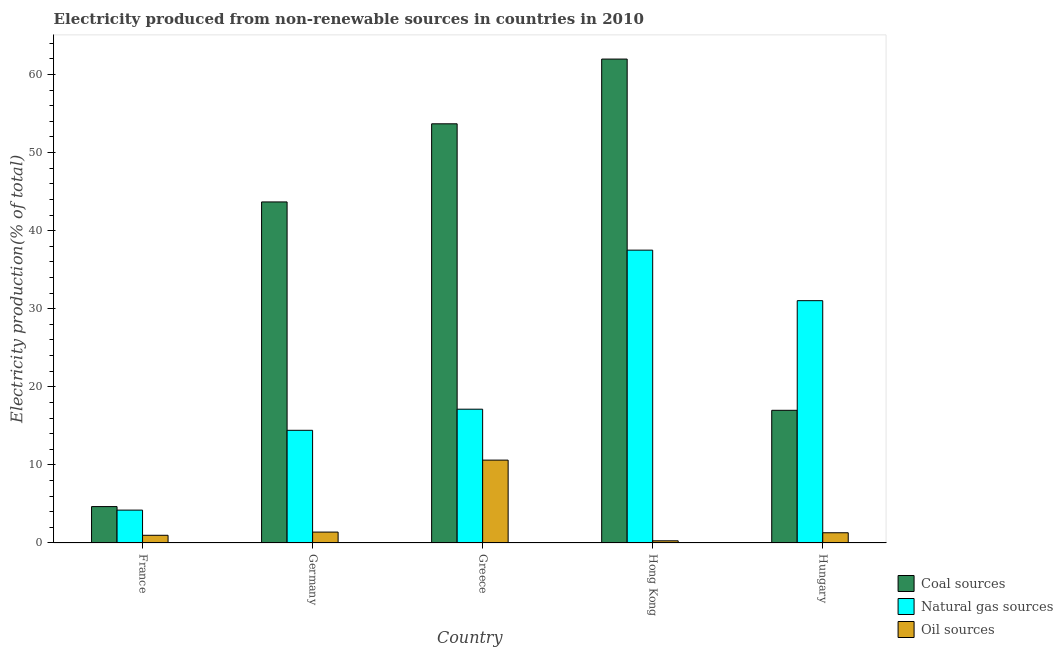How many different coloured bars are there?
Offer a very short reply. 3. How many groups of bars are there?
Make the answer very short. 5. Are the number of bars on each tick of the X-axis equal?
Ensure brevity in your answer.  Yes. What is the label of the 4th group of bars from the left?
Your answer should be compact. Hong Kong. In how many cases, is the number of bars for a given country not equal to the number of legend labels?
Provide a succinct answer. 0. What is the percentage of electricity produced by coal in France?
Give a very brief answer. 4.66. Across all countries, what is the maximum percentage of electricity produced by coal?
Make the answer very short. 61.98. Across all countries, what is the minimum percentage of electricity produced by natural gas?
Your answer should be compact. 4.21. In which country was the percentage of electricity produced by oil sources minimum?
Provide a succinct answer. Hong Kong. What is the total percentage of electricity produced by oil sources in the graph?
Provide a short and direct response. 14.59. What is the difference between the percentage of electricity produced by coal in Hong Kong and that in Hungary?
Ensure brevity in your answer.  44.98. What is the difference between the percentage of electricity produced by natural gas in Hong Kong and the percentage of electricity produced by oil sources in Greece?
Make the answer very short. 26.89. What is the average percentage of electricity produced by oil sources per country?
Your answer should be compact. 2.92. What is the difference between the percentage of electricity produced by natural gas and percentage of electricity produced by oil sources in France?
Provide a succinct answer. 3.22. In how many countries, is the percentage of electricity produced by oil sources greater than 48 %?
Make the answer very short. 0. What is the ratio of the percentage of electricity produced by natural gas in France to that in Germany?
Keep it short and to the point. 0.29. Is the percentage of electricity produced by natural gas in France less than that in Germany?
Your response must be concise. Yes. What is the difference between the highest and the second highest percentage of electricity produced by coal?
Give a very brief answer. 8.29. What is the difference between the highest and the lowest percentage of electricity produced by oil sources?
Offer a terse response. 10.34. In how many countries, is the percentage of electricity produced by natural gas greater than the average percentage of electricity produced by natural gas taken over all countries?
Your answer should be very brief. 2. Is the sum of the percentage of electricity produced by natural gas in France and Greece greater than the maximum percentage of electricity produced by coal across all countries?
Your answer should be compact. No. What does the 2nd bar from the left in Hungary represents?
Ensure brevity in your answer.  Natural gas sources. What does the 1st bar from the right in Germany represents?
Your response must be concise. Oil sources. What is the difference between two consecutive major ticks on the Y-axis?
Offer a very short reply. 10. Does the graph contain any zero values?
Provide a succinct answer. No. How many legend labels are there?
Ensure brevity in your answer.  3. How are the legend labels stacked?
Give a very brief answer. Vertical. What is the title of the graph?
Your answer should be very brief. Electricity produced from non-renewable sources in countries in 2010. What is the Electricity production(% of total) of Coal sources in France?
Make the answer very short. 4.66. What is the Electricity production(% of total) of Natural gas sources in France?
Make the answer very short. 4.21. What is the Electricity production(% of total) of Oil sources in France?
Make the answer very short. 0.99. What is the Electricity production(% of total) of Coal sources in Germany?
Your response must be concise. 43.68. What is the Electricity production(% of total) in Natural gas sources in Germany?
Offer a very short reply. 14.43. What is the Electricity production(% of total) of Oil sources in Germany?
Ensure brevity in your answer.  1.4. What is the Electricity production(% of total) of Coal sources in Greece?
Offer a terse response. 53.68. What is the Electricity production(% of total) in Natural gas sources in Greece?
Provide a succinct answer. 17.14. What is the Electricity production(% of total) of Oil sources in Greece?
Your answer should be compact. 10.61. What is the Electricity production(% of total) of Coal sources in Hong Kong?
Provide a succinct answer. 61.98. What is the Electricity production(% of total) in Natural gas sources in Hong Kong?
Keep it short and to the point. 37.5. What is the Electricity production(% of total) of Oil sources in Hong Kong?
Ensure brevity in your answer.  0.28. What is the Electricity production(% of total) of Coal sources in Hungary?
Your answer should be very brief. 16.99. What is the Electricity production(% of total) of Natural gas sources in Hungary?
Your answer should be compact. 31.03. What is the Electricity production(% of total) in Oil sources in Hungary?
Offer a terse response. 1.31. Across all countries, what is the maximum Electricity production(% of total) of Coal sources?
Your response must be concise. 61.98. Across all countries, what is the maximum Electricity production(% of total) in Natural gas sources?
Give a very brief answer. 37.5. Across all countries, what is the maximum Electricity production(% of total) of Oil sources?
Give a very brief answer. 10.61. Across all countries, what is the minimum Electricity production(% of total) of Coal sources?
Offer a terse response. 4.66. Across all countries, what is the minimum Electricity production(% of total) in Natural gas sources?
Provide a succinct answer. 4.21. Across all countries, what is the minimum Electricity production(% of total) of Oil sources?
Your answer should be compact. 0.28. What is the total Electricity production(% of total) in Coal sources in the graph?
Provide a succinct answer. 180.99. What is the total Electricity production(% of total) of Natural gas sources in the graph?
Your response must be concise. 104.32. What is the total Electricity production(% of total) of Oil sources in the graph?
Offer a terse response. 14.59. What is the difference between the Electricity production(% of total) in Coal sources in France and that in Germany?
Ensure brevity in your answer.  -39.02. What is the difference between the Electricity production(% of total) in Natural gas sources in France and that in Germany?
Your response must be concise. -10.22. What is the difference between the Electricity production(% of total) in Oil sources in France and that in Germany?
Your answer should be very brief. -0.41. What is the difference between the Electricity production(% of total) in Coal sources in France and that in Greece?
Provide a succinct answer. -49.02. What is the difference between the Electricity production(% of total) of Natural gas sources in France and that in Greece?
Provide a short and direct response. -12.93. What is the difference between the Electricity production(% of total) of Oil sources in France and that in Greece?
Your answer should be very brief. -9.63. What is the difference between the Electricity production(% of total) in Coal sources in France and that in Hong Kong?
Your answer should be very brief. -57.31. What is the difference between the Electricity production(% of total) of Natural gas sources in France and that in Hong Kong?
Provide a succinct answer. -33.29. What is the difference between the Electricity production(% of total) of Oil sources in France and that in Hong Kong?
Make the answer very short. 0.71. What is the difference between the Electricity production(% of total) of Coal sources in France and that in Hungary?
Keep it short and to the point. -12.33. What is the difference between the Electricity production(% of total) in Natural gas sources in France and that in Hungary?
Keep it short and to the point. -26.82. What is the difference between the Electricity production(% of total) of Oil sources in France and that in Hungary?
Give a very brief answer. -0.33. What is the difference between the Electricity production(% of total) of Coal sources in Germany and that in Greece?
Offer a very short reply. -10. What is the difference between the Electricity production(% of total) in Natural gas sources in Germany and that in Greece?
Your answer should be compact. -2.7. What is the difference between the Electricity production(% of total) in Oil sources in Germany and that in Greece?
Your response must be concise. -9.22. What is the difference between the Electricity production(% of total) in Coal sources in Germany and that in Hong Kong?
Make the answer very short. -18.3. What is the difference between the Electricity production(% of total) of Natural gas sources in Germany and that in Hong Kong?
Provide a succinct answer. -23.07. What is the difference between the Electricity production(% of total) of Oil sources in Germany and that in Hong Kong?
Offer a very short reply. 1.12. What is the difference between the Electricity production(% of total) of Coal sources in Germany and that in Hungary?
Give a very brief answer. 26.69. What is the difference between the Electricity production(% of total) of Natural gas sources in Germany and that in Hungary?
Your answer should be compact. -16.6. What is the difference between the Electricity production(% of total) in Oil sources in Germany and that in Hungary?
Your answer should be very brief. 0.09. What is the difference between the Electricity production(% of total) in Coal sources in Greece and that in Hong Kong?
Give a very brief answer. -8.29. What is the difference between the Electricity production(% of total) of Natural gas sources in Greece and that in Hong Kong?
Make the answer very short. -20.37. What is the difference between the Electricity production(% of total) in Oil sources in Greece and that in Hong Kong?
Ensure brevity in your answer.  10.34. What is the difference between the Electricity production(% of total) of Coal sources in Greece and that in Hungary?
Keep it short and to the point. 36.69. What is the difference between the Electricity production(% of total) of Natural gas sources in Greece and that in Hungary?
Ensure brevity in your answer.  -13.9. What is the difference between the Electricity production(% of total) in Oil sources in Greece and that in Hungary?
Offer a terse response. 9.3. What is the difference between the Electricity production(% of total) in Coal sources in Hong Kong and that in Hungary?
Offer a very short reply. 44.98. What is the difference between the Electricity production(% of total) in Natural gas sources in Hong Kong and that in Hungary?
Your answer should be very brief. 6.47. What is the difference between the Electricity production(% of total) in Oil sources in Hong Kong and that in Hungary?
Keep it short and to the point. -1.03. What is the difference between the Electricity production(% of total) of Coal sources in France and the Electricity production(% of total) of Natural gas sources in Germany?
Provide a short and direct response. -9.77. What is the difference between the Electricity production(% of total) in Coal sources in France and the Electricity production(% of total) in Oil sources in Germany?
Ensure brevity in your answer.  3.27. What is the difference between the Electricity production(% of total) of Natural gas sources in France and the Electricity production(% of total) of Oil sources in Germany?
Ensure brevity in your answer.  2.81. What is the difference between the Electricity production(% of total) in Coal sources in France and the Electricity production(% of total) in Natural gas sources in Greece?
Provide a short and direct response. -12.47. What is the difference between the Electricity production(% of total) in Coal sources in France and the Electricity production(% of total) in Oil sources in Greece?
Make the answer very short. -5.95. What is the difference between the Electricity production(% of total) in Natural gas sources in France and the Electricity production(% of total) in Oil sources in Greece?
Your response must be concise. -6.4. What is the difference between the Electricity production(% of total) of Coal sources in France and the Electricity production(% of total) of Natural gas sources in Hong Kong?
Offer a terse response. -32.84. What is the difference between the Electricity production(% of total) in Coal sources in France and the Electricity production(% of total) in Oil sources in Hong Kong?
Your answer should be very brief. 4.38. What is the difference between the Electricity production(% of total) in Natural gas sources in France and the Electricity production(% of total) in Oil sources in Hong Kong?
Your answer should be compact. 3.93. What is the difference between the Electricity production(% of total) of Coal sources in France and the Electricity production(% of total) of Natural gas sources in Hungary?
Offer a very short reply. -26.37. What is the difference between the Electricity production(% of total) in Coal sources in France and the Electricity production(% of total) in Oil sources in Hungary?
Provide a succinct answer. 3.35. What is the difference between the Electricity production(% of total) in Natural gas sources in France and the Electricity production(% of total) in Oil sources in Hungary?
Ensure brevity in your answer.  2.9. What is the difference between the Electricity production(% of total) of Coal sources in Germany and the Electricity production(% of total) of Natural gas sources in Greece?
Keep it short and to the point. 26.54. What is the difference between the Electricity production(% of total) of Coal sources in Germany and the Electricity production(% of total) of Oil sources in Greece?
Offer a very short reply. 33.07. What is the difference between the Electricity production(% of total) of Natural gas sources in Germany and the Electricity production(% of total) of Oil sources in Greece?
Offer a very short reply. 3.82. What is the difference between the Electricity production(% of total) in Coal sources in Germany and the Electricity production(% of total) in Natural gas sources in Hong Kong?
Offer a very short reply. 6.18. What is the difference between the Electricity production(% of total) in Coal sources in Germany and the Electricity production(% of total) in Oil sources in Hong Kong?
Your answer should be very brief. 43.4. What is the difference between the Electricity production(% of total) of Natural gas sources in Germany and the Electricity production(% of total) of Oil sources in Hong Kong?
Provide a short and direct response. 14.15. What is the difference between the Electricity production(% of total) of Coal sources in Germany and the Electricity production(% of total) of Natural gas sources in Hungary?
Ensure brevity in your answer.  12.64. What is the difference between the Electricity production(% of total) of Coal sources in Germany and the Electricity production(% of total) of Oil sources in Hungary?
Offer a very short reply. 42.37. What is the difference between the Electricity production(% of total) in Natural gas sources in Germany and the Electricity production(% of total) in Oil sources in Hungary?
Give a very brief answer. 13.12. What is the difference between the Electricity production(% of total) in Coal sources in Greece and the Electricity production(% of total) in Natural gas sources in Hong Kong?
Your answer should be very brief. 16.18. What is the difference between the Electricity production(% of total) in Coal sources in Greece and the Electricity production(% of total) in Oil sources in Hong Kong?
Your answer should be very brief. 53.41. What is the difference between the Electricity production(% of total) of Natural gas sources in Greece and the Electricity production(% of total) of Oil sources in Hong Kong?
Provide a succinct answer. 16.86. What is the difference between the Electricity production(% of total) of Coal sources in Greece and the Electricity production(% of total) of Natural gas sources in Hungary?
Keep it short and to the point. 22.65. What is the difference between the Electricity production(% of total) in Coal sources in Greece and the Electricity production(% of total) in Oil sources in Hungary?
Ensure brevity in your answer.  52.37. What is the difference between the Electricity production(% of total) of Natural gas sources in Greece and the Electricity production(% of total) of Oil sources in Hungary?
Your answer should be very brief. 15.82. What is the difference between the Electricity production(% of total) of Coal sources in Hong Kong and the Electricity production(% of total) of Natural gas sources in Hungary?
Offer a very short reply. 30.94. What is the difference between the Electricity production(% of total) of Coal sources in Hong Kong and the Electricity production(% of total) of Oil sources in Hungary?
Provide a short and direct response. 60.66. What is the difference between the Electricity production(% of total) in Natural gas sources in Hong Kong and the Electricity production(% of total) in Oil sources in Hungary?
Offer a terse response. 36.19. What is the average Electricity production(% of total) of Coal sources per country?
Ensure brevity in your answer.  36.2. What is the average Electricity production(% of total) of Natural gas sources per country?
Keep it short and to the point. 20.86. What is the average Electricity production(% of total) of Oil sources per country?
Your answer should be compact. 2.92. What is the difference between the Electricity production(% of total) of Coal sources and Electricity production(% of total) of Natural gas sources in France?
Your response must be concise. 0.45. What is the difference between the Electricity production(% of total) in Coal sources and Electricity production(% of total) in Oil sources in France?
Offer a terse response. 3.68. What is the difference between the Electricity production(% of total) in Natural gas sources and Electricity production(% of total) in Oil sources in France?
Keep it short and to the point. 3.22. What is the difference between the Electricity production(% of total) in Coal sources and Electricity production(% of total) in Natural gas sources in Germany?
Ensure brevity in your answer.  29.25. What is the difference between the Electricity production(% of total) in Coal sources and Electricity production(% of total) in Oil sources in Germany?
Offer a terse response. 42.28. What is the difference between the Electricity production(% of total) in Natural gas sources and Electricity production(% of total) in Oil sources in Germany?
Ensure brevity in your answer.  13.04. What is the difference between the Electricity production(% of total) of Coal sources and Electricity production(% of total) of Natural gas sources in Greece?
Your answer should be very brief. 36.55. What is the difference between the Electricity production(% of total) in Coal sources and Electricity production(% of total) in Oil sources in Greece?
Provide a short and direct response. 43.07. What is the difference between the Electricity production(% of total) of Natural gas sources and Electricity production(% of total) of Oil sources in Greece?
Provide a succinct answer. 6.52. What is the difference between the Electricity production(% of total) in Coal sources and Electricity production(% of total) in Natural gas sources in Hong Kong?
Make the answer very short. 24.47. What is the difference between the Electricity production(% of total) of Coal sources and Electricity production(% of total) of Oil sources in Hong Kong?
Ensure brevity in your answer.  61.7. What is the difference between the Electricity production(% of total) of Natural gas sources and Electricity production(% of total) of Oil sources in Hong Kong?
Offer a terse response. 37.23. What is the difference between the Electricity production(% of total) of Coal sources and Electricity production(% of total) of Natural gas sources in Hungary?
Provide a short and direct response. -14.04. What is the difference between the Electricity production(% of total) in Coal sources and Electricity production(% of total) in Oil sources in Hungary?
Keep it short and to the point. 15.68. What is the difference between the Electricity production(% of total) of Natural gas sources and Electricity production(% of total) of Oil sources in Hungary?
Keep it short and to the point. 29.72. What is the ratio of the Electricity production(% of total) in Coal sources in France to that in Germany?
Keep it short and to the point. 0.11. What is the ratio of the Electricity production(% of total) in Natural gas sources in France to that in Germany?
Offer a very short reply. 0.29. What is the ratio of the Electricity production(% of total) in Oil sources in France to that in Germany?
Offer a terse response. 0.71. What is the ratio of the Electricity production(% of total) in Coal sources in France to that in Greece?
Your answer should be very brief. 0.09. What is the ratio of the Electricity production(% of total) of Natural gas sources in France to that in Greece?
Ensure brevity in your answer.  0.25. What is the ratio of the Electricity production(% of total) in Oil sources in France to that in Greece?
Your response must be concise. 0.09. What is the ratio of the Electricity production(% of total) of Coal sources in France to that in Hong Kong?
Keep it short and to the point. 0.08. What is the ratio of the Electricity production(% of total) in Natural gas sources in France to that in Hong Kong?
Make the answer very short. 0.11. What is the ratio of the Electricity production(% of total) of Oil sources in France to that in Hong Kong?
Your answer should be very brief. 3.54. What is the ratio of the Electricity production(% of total) of Coal sources in France to that in Hungary?
Offer a very short reply. 0.27. What is the ratio of the Electricity production(% of total) in Natural gas sources in France to that in Hungary?
Your response must be concise. 0.14. What is the ratio of the Electricity production(% of total) in Oil sources in France to that in Hungary?
Keep it short and to the point. 0.75. What is the ratio of the Electricity production(% of total) of Coal sources in Germany to that in Greece?
Make the answer very short. 0.81. What is the ratio of the Electricity production(% of total) in Natural gas sources in Germany to that in Greece?
Your answer should be compact. 0.84. What is the ratio of the Electricity production(% of total) in Oil sources in Germany to that in Greece?
Your answer should be very brief. 0.13. What is the ratio of the Electricity production(% of total) in Coal sources in Germany to that in Hong Kong?
Provide a succinct answer. 0.7. What is the ratio of the Electricity production(% of total) in Natural gas sources in Germany to that in Hong Kong?
Provide a succinct answer. 0.38. What is the ratio of the Electricity production(% of total) in Oil sources in Germany to that in Hong Kong?
Provide a succinct answer. 5.01. What is the ratio of the Electricity production(% of total) of Coal sources in Germany to that in Hungary?
Your answer should be compact. 2.57. What is the ratio of the Electricity production(% of total) in Natural gas sources in Germany to that in Hungary?
Provide a succinct answer. 0.47. What is the ratio of the Electricity production(% of total) in Oil sources in Germany to that in Hungary?
Offer a terse response. 1.06. What is the ratio of the Electricity production(% of total) in Coal sources in Greece to that in Hong Kong?
Make the answer very short. 0.87. What is the ratio of the Electricity production(% of total) in Natural gas sources in Greece to that in Hong Kong?
Ensure brevity in your answer.  0.46. What is the ratio of the Electricity production(% of total) of Oil sources in Greece to that in Hong Kong?
Provide a succinct answer. 38.08. What is the ratio of the Electricity production(% of total) in Coal sources in Greece to that in Hungary?
Provide a short and direct response. 3.16. What is the ratio of the Electricity production(% of total) of Natural gas sources in Greece to that in Hungary?
Your answer should be compact. 0.55. What is the ratio of the Electricity production(% of total) of Oil sources in Greece to that in Hungary?
Provide a short and direct response. 8.1. What is the ratio of the Electricity production(% of total) in Coal sources in Hong Kong to that in Hungary?
Offer a terse response. 3.65. What is the ratio of the Electricity production(% of total) in Natural gas sources in Hong Kong to that in Hungary?
Your answer should be compact. 1.21. What is the ratio of the Electricity production(% of total) of Oil sources in Hong Kong to that in Hungary?
Make the answer very short. 0.21. What is the difference between the highest and the second highest Electricity production(% of total) in Coal sources?
Your response must be concise. 8.29. What is the difference between the highest and the second highest Electricity production(% of total) in Natural gas sources?
Provide a short and direct response. 6.47. What is the difference between the highest and the second highest Electricity production(% of total) in Oil sources?
Provide a short and direct response. 9.22. What is the difference between the highest and the lowest Electricity production(% of total) in Coal sources?
Keep it short and to the point. 57.31. What is the difference between the highest and the lowest Electricity production(% of total) of Natural gas sources?
Provide a succinct answer. 33.29. What is the difference between the highest and the lowest Electricity production(% of total) in Oil sources?
Give a very brief answer. 10.34. 